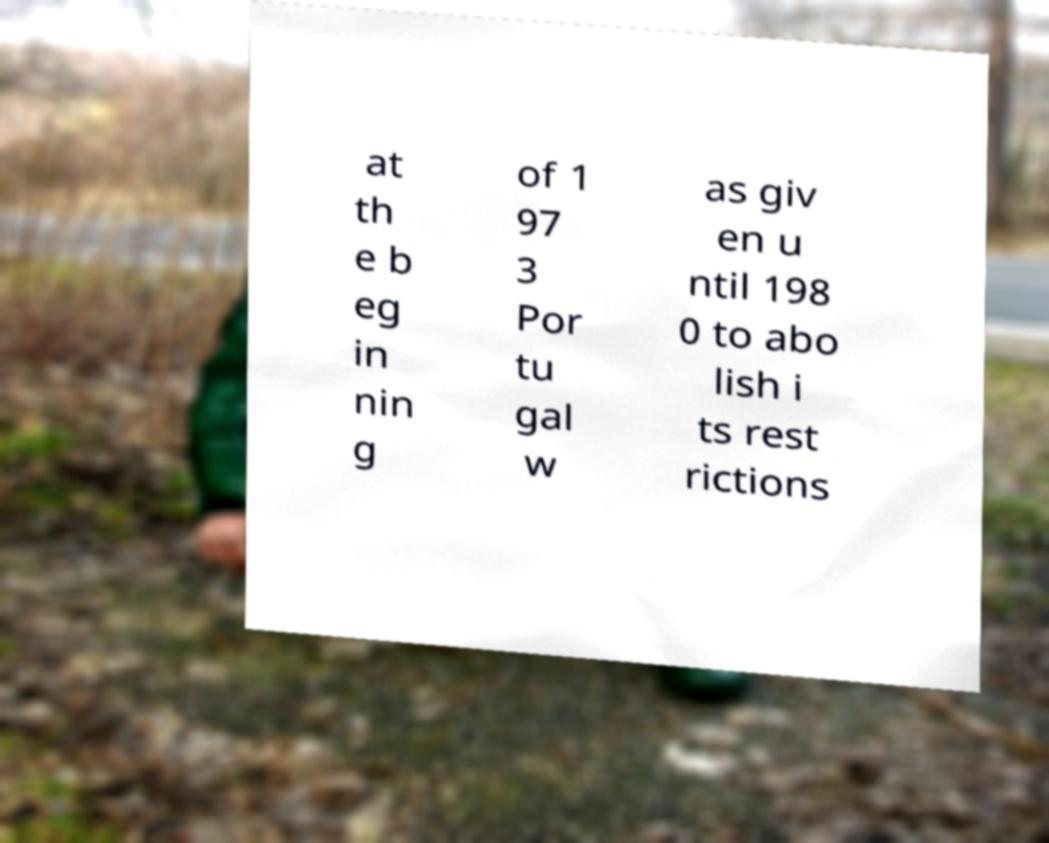Please read and relay the text visible in this image. What does it say? at th e b eg in nin g of 1 97 3 Por tu gal w as giv en u ntil 198 0 to abo lish i ts rest rictions 